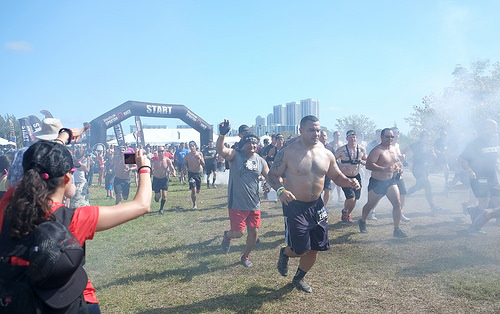<image>
Is the guy in front of the man? Yes. The guy is positioned in front of the man, appearing closer to the camera viewpoint. 